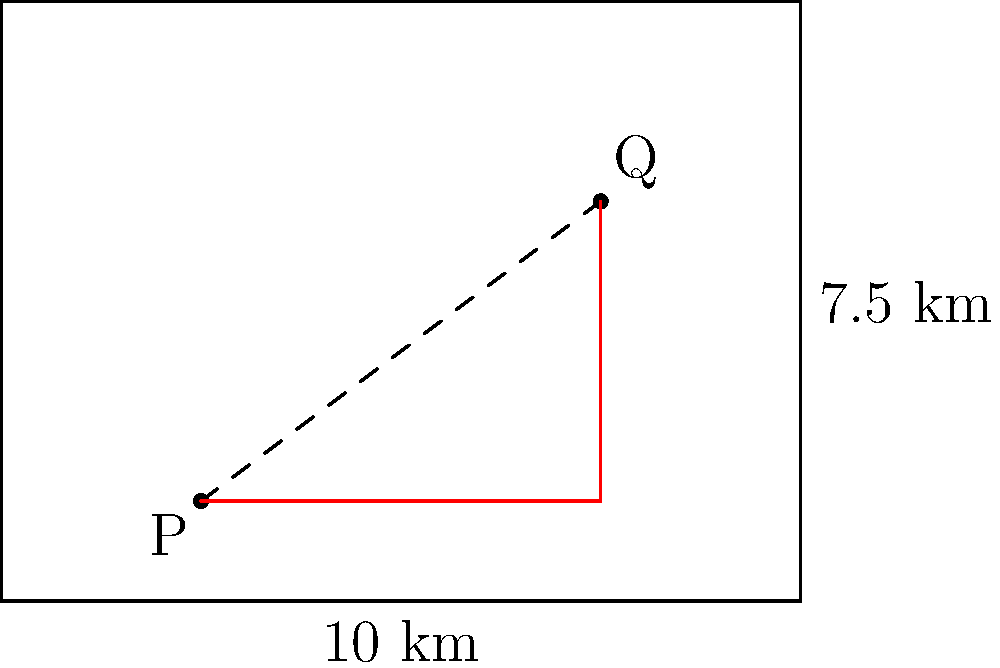In a rectangular conservation area measuring 10 km by 7.5 km, two endangered insect populations are located at points P(2,1) and Q(6,4), where coordinates are given in kilometers from the southwest corner. What is the shortest distance between these two populations, rounded to two decimal places? To find the shortest distance between two points in a plane, we typically use the straight line distance. However, in this case, we need to consider if there's a shorter path along the edges of the rectangle.

Let's approach this step-by-step:

1) First, calculate the straight-line distance using the distance formula:
   $$d = \sqrt{(x_2-x_1)^2 + (y_2-y_1)^2}$$
   $$d = \sqrt{(6-2)^2 + (4-1)^2} = \sqrt{16 + 9} = \sqrt{25} = 5$$ km

2) Now, let's consider the path along the edges:
   - From P to (6,1): 4 km
   - From (6,1) to Q: 3 km
   Total: 4 + 3 = 7 km

3) The straight-line distance (5 km) is shorter than the edge path (7 km).

Therefore, the shortest distance between the two populations is 5 km.

Rounding to two decimal places: 5.00 km.
Answer: 5.00 km 